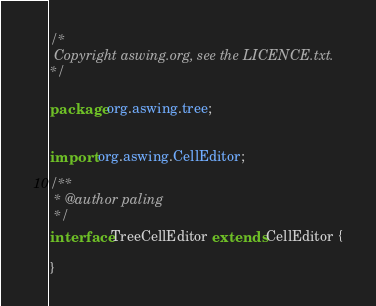Convert code to text. <code><loc_0><loc_0><loc_500><loc_500><_Haxe_>/*
 Copyright aswing.org, see the LICENCE.txt.
*/

package org.aswing.tree;


import org.aswing.CellEditor;

/**
 * @author paling
 */
interface TreeCellEditor extends CellEditor {

}</code> 